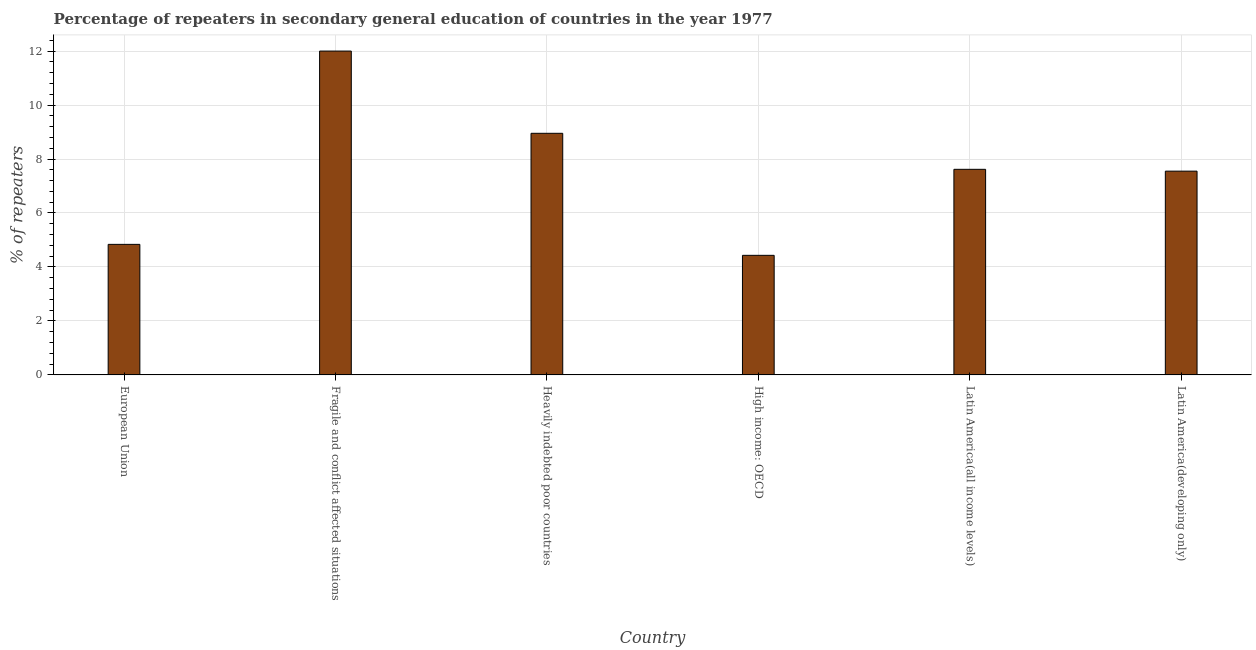What is the title of the graph?
Provide a succinct answer. Percentage of repeaters in secondary general education of countries in the year 1977. What is the label or title of the X-axis?
Your answer should be very brief. Country. What is the label or title of the Y-axis?
Make the answer very short. % of repeaters. What is the percentage of repeaters in Latin America(all income levels)?
Provide a succinct answer. 7.62. Across all countries, what is the maximum percentage of repeaters?
Provide a short and direct response. 12. Across all countries, what is the minimum percentage of repeaters?
Offer a very short reply. 4.43. In which country was the percentage of repeaters maximum?
Ensure brevity in your answer.  Fragile and conflict affected situations. In which country was the percentage of repeaters minimum?
Your response must be concise. High income: OECD. What is the sum of the percentage of repeaters?
Offer a very short reply. 45.39. What is the difference between the percentage of repeaters in European Union and Fragile and conflict affected situations?
Your response must be concise. -7.16. What is the average percentage of repeaters per country?
Ensure brevity in your answer.  7.57. What is the median percentage of repeaters?
Offer a terse response. 7.58. What is the ratio of the percentage of repeaters in Heavily indebted poor countries to that in Latin America(all income levels)?
Provide a short and direct response. 1.18. What is the difference between the highest and the second highest percentage of repeaters?
Offer a very short reply. 3.05. Is the sum of the percentage of repeaters in Heavily indebted poor countries and Latin America(developing only) greater than the maximum percentage of repeaters across all countries?
Your answer should be very brief. Yes. What is the difference between the highest and the lowest percentage of repeaters?
Provide a short and direct response. 7.57. How many bars are there?
Make the answer very short. 6. How many countries are there in the graph?
Offer a terse response. 6. What is the difference between two consecutive major ticks on the Y-axis?
Ensure brevity in your answer.  2. What is the % of repeaters of European Union?
Give a very brief answer. 4.84. What is the % of repeaters of Fragile and conflict affected situations?
Ensure brevity in your answer.  12. What is the % of repeaters of Heavily indebted poor countries?
Your answer should be very brief. 8.95. What is the % of repeaters of High income: OECD?
Your answer should be compact. 4.43. What is the % of repeaters in Latin America(all income levels)?
Offer a very short reply. 7.62. What is the % of repeaters in Latin America(developing only)?
Provide a short and direct response. 7.55. What is the difference between the % of repeaters in European Union and Fragile and conflict affected situations?
Keep it short and to the point. -7.16. What is the difference between the % of repeaters in European Union and Heavily indebted poor countries?
Offer a terse response. -4.12. What is the difference between the % of repeaters in European Union and High income: OECD?
Provide a short and direct response. 0.41. What is the difference between the % of repeaters in European Union and Latin America(all income levels)?
Offer a very short reply. -2.78. What is the difference between the % of repeaters in European Union and Latin America(developing only)?
Your answer should be very brief. -2.71. What is the difference between the % of repeaters in Fragile and conflict affected situations and Heavily indebted poor countries?
Keep it short and to the point. 3.05. What is the difference between the % of repeaters in Fragile and conflict affected situations and High income: OECD?
Ensure brevity in your answer.  7.57. What is the difference between the % of repeaters in Fragile and conflict affected situations and Latin America(all income levels)?
Offer a very short reply. 4.38. What is the difference between the % of repeaters in Fragile and conflict affected situations and Latin America(developing only)?
Your response must be concise. 4.45. What is the difference between the % of repeaters in Heavily indebted poor countries and High income: OECD?
Your response must be concise. 4.52. What is the difference between the % of repeaters in Heavily indebted poor countries and Latin America(all income levels)?
Ensure brevity in your answer.  1.33. What is the difference between the % of repeaters in Heavily indebted poor countries and Latin America(developing only)?
Your answer should be compact. 1.4. What is the difference between the % of repeaters in High income: OECD and Latin America(all income levels)?
Give a very brief answer. -3.19. What is the difference between the % of repeaters in High income: OECD and Latin America(developing only)?
Give a very brief answer. -3.12. What is the difference between the % of repeaters in Latin America(all income levels) and Latin America(developing only)?
Make the answer very short. 0.07. What is the ratio of the % of repeaters in European Union to that in Fragile and conflict affected situations?
Your answer should be compact. 0.4. What is the ratio of the % of repeaters in European Union to that in Heavily indebted poor countries?
Provide a succinct answer. 0.54. What is the ratio of the % of repeaters in European Union to that in High income: OECD?
Offer a very short reply. 1.09. What is the ratio of the % of repeaters in European Union to that in Latin America(all income levels)?
Ensure brevity in your answer.  0.64. What is the ratio of the % of repeaters in European Union to that in Latin America(developing only)?
Offer a very short reply. 0.64. What is the ratio of the % of repeaters in Fragile and conflict affected situations to that in Heavily indebted poor countries?
Provide a short and direct response. 1.34. What is the ratio of the % of repeaters in Fragile and conflict affected situations to that in High income: OECD?
Your answer should be very brief. 2.71. What is the ratio of the % of repeaters in Fragile and conflict affected situations to that in Latin America(all income levels)?
Keep it short and to the point. 1.57. What is the ratio of the % of repeaters in Fragile and conflict affected situations to that in Latin America(developing only)?
Offer a very short reply. 1.59. What is the ratio of the % of repeaters in Heavily indebted poor countries to that in High income: OECD?
Offer a terse response. 2.02. What is the ratio of the % of repeaters in Heavily indebted poor countries to that in Latin America(all income levels)?
Provide a short and direct response. 1.18. What is the ratio of the % of repeaters in Heavily indebted poor countries to that in Latin America(developing only)?
Provide a succinct answer. 1.19. What is the ratio of the % of repeaters in High income: OECD to that in Latin America(all income levels)?
Your answer should be compact. 0.58. What is the ratio of the % of repeaters in High income: OECD to that in Latin America(developing only)?
Offer a terse response. 0.59. 